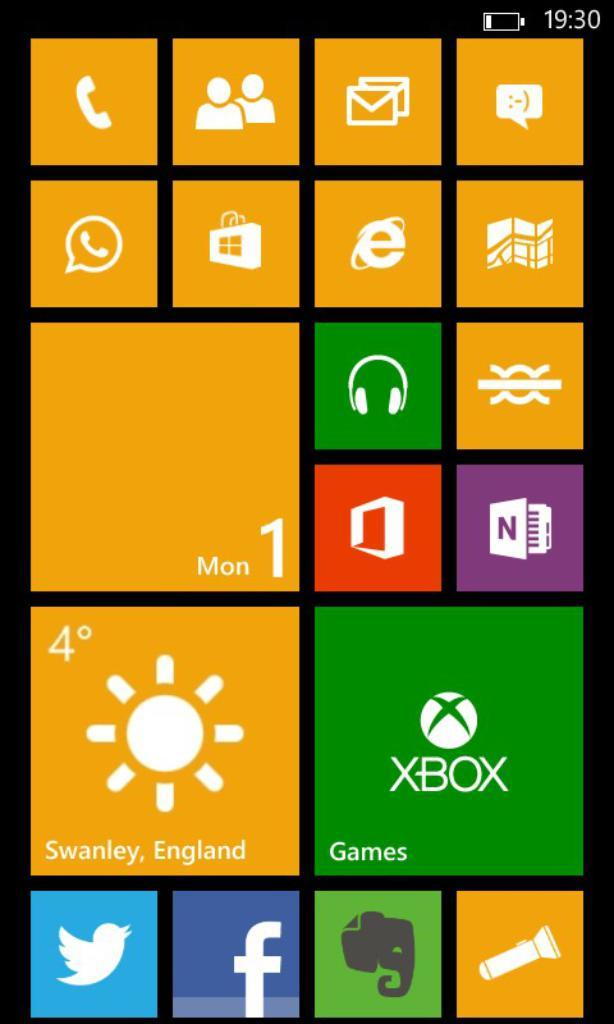<image>
Provide a brief description of the given image. The menu of an electronic device features a Games option. 